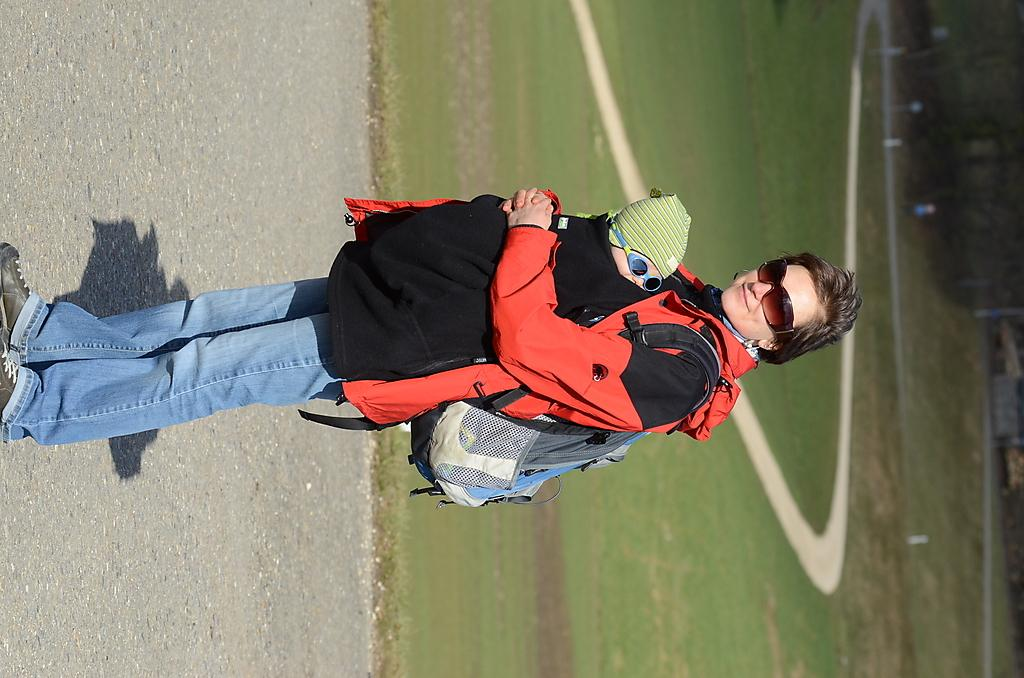Who is the main subject in the image? There is a lady in the image. What is the lady doing in the image? The lady is holding a baby. What are the lady and the baby wearing in the image? Both the lady and the baby are wearing goggles. What can be seen below the subjects in the image? There is a ground visible in the image. What word is the lady saying to the baby in the image? There is no indication of any spoken words in the image, so it cannot be determined what the lady might be saying to the baby. 